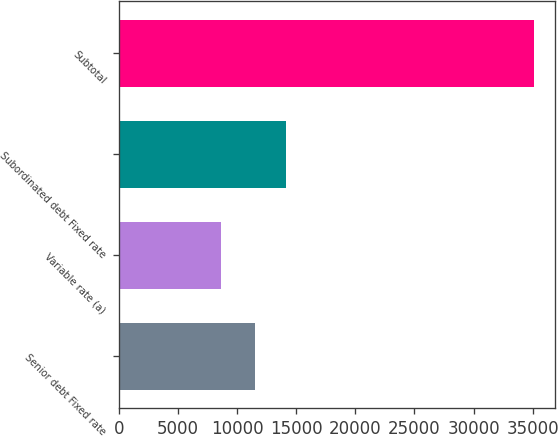<chart> <loc_0><loc_0><loc_500><loc_500><bar_chart><fcel>Senior debt Fixed rate<fcel>Variable rate (a)<fcel>Subordinated debt Fixed rate<fcel>Subtotal<nl><fcel>11516<fcel>8657<fcel>14159.8<fcel>35095<nl></chart> 